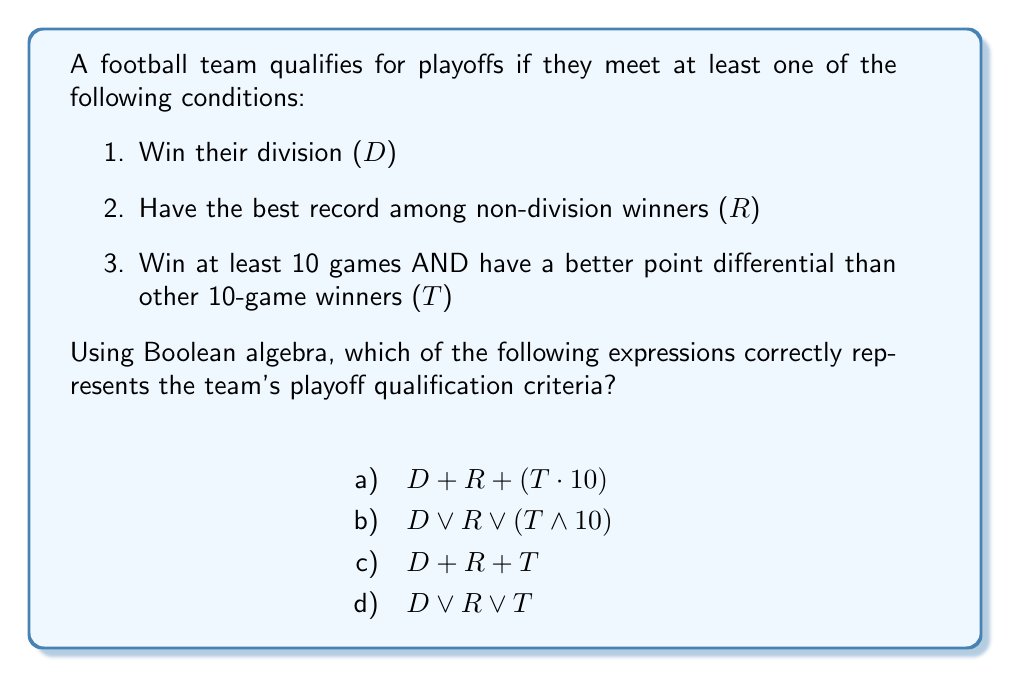Provide a solution to this math problem. Let's break this down step-by-step:

1. We need to represent the playoff qualification criteria using Boolean algebra.

2. The team qualifies if they meet ANY of the three conditions, which in Boolean algebra is represented by the OR operation (symbolized by $\lor$ or $+$).

3. The first two conditions (D and R) are straightforward and can be directly used in the expression.

4. The third condition (T) is a compound condition:
   - Win at least 10 games AND
   - Have a better point differential than other 10-game winners
   This is represented by T in our options, as it combines both parts of the condition.

5. The correct expression should include all three conditions connected by OR operations.

6. Looking at the options:
   a) $D + R + (T \cdot 10)$ is incorrect because it treats the 10-game requirement as a separate factor.
   b) $D \lor R \lor (T \land 10)$ is incorrect for the same reason as a).
   c) $D + R + T$ is correct, using $+$ to represent OR.
   d) $D \lor R \lor T$ is also correct, using $\lor$ to represent OR.

7. Both c) and d) are mathematically equivalent and correctly represent the playoff qualification criteria.
Answer: c) $D + R + T$ or d) $D \lor R \lor T$ 